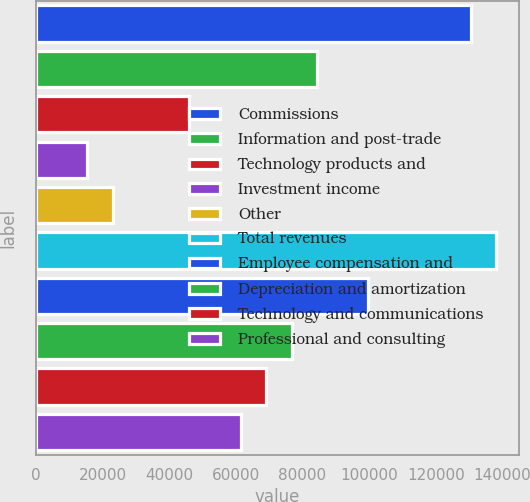<chart> <loc_0><loc_0><loc_500><loc_500><bar_chart><fcel>Commissions<fcel>Information and post-trade<fcel>Technology products and<fcel>Investment income<fcel>Other<fcel>Total revenues<fcel>Employee compensation and<fcel>Depreciation and amortization<fcel>Technology and communications<fcel>Professional and consulting<nl><fcel>130510<fcel>84448.1<fcel>46062.9<fcel>15354.7<fcel>23031.8<fcel>138187<fcel>99802.1<fcel>76771<fcel>69094<fcel>61416.9<nl></chart> 